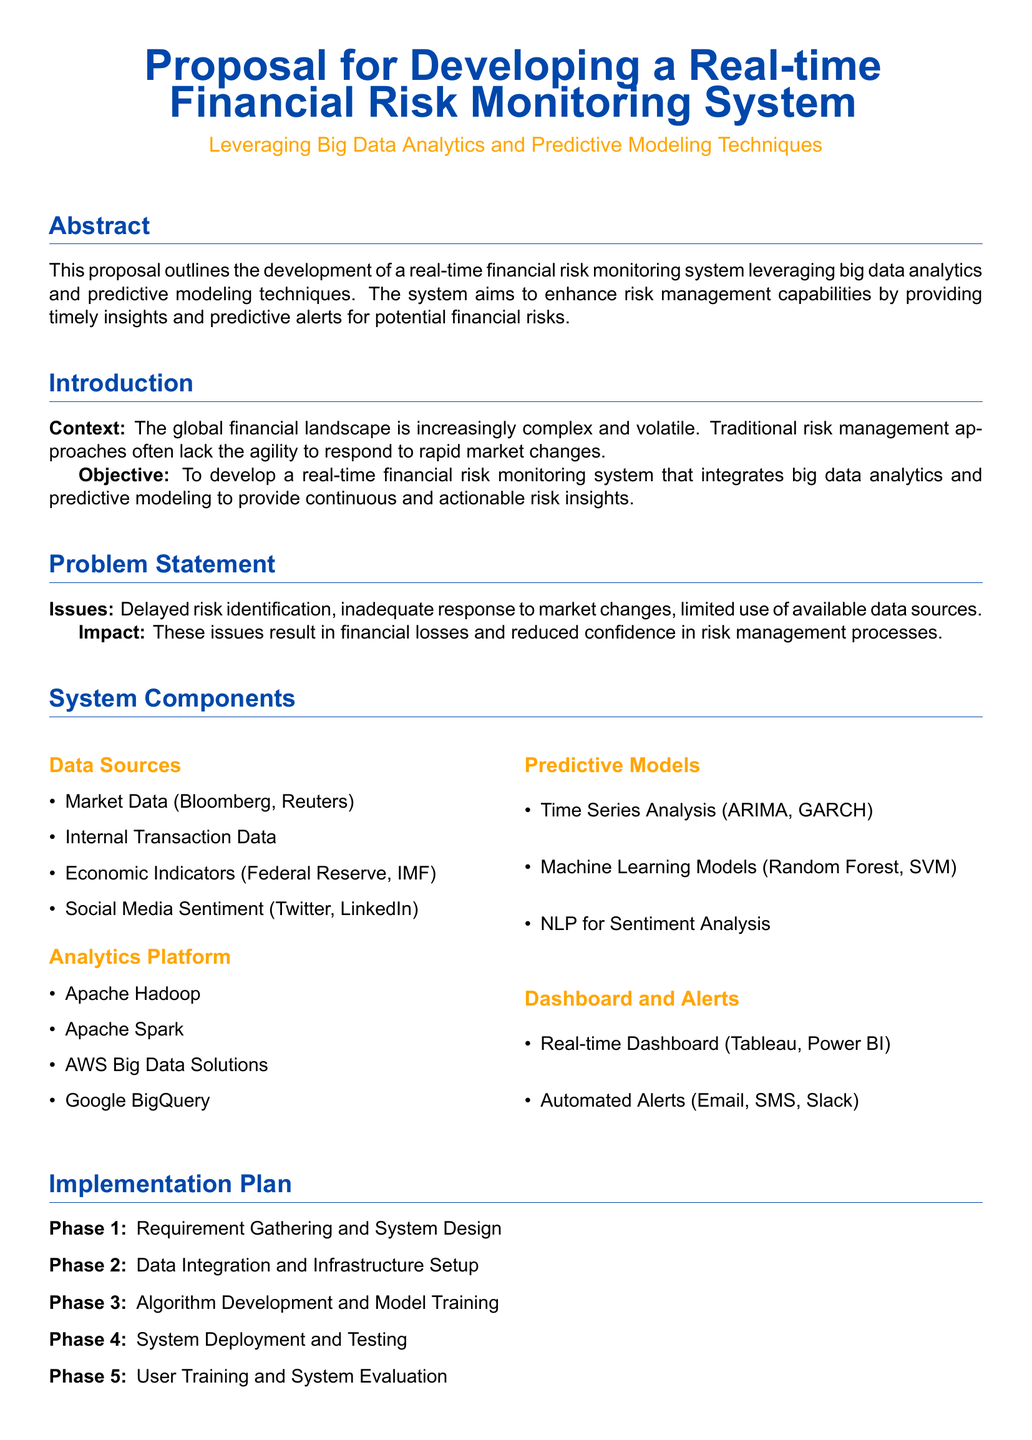What is the main aim of the proposal? The main aim of the proposal is to enhance risk management capabilities by providing timely insights and predictive alerts for potential financial risks.
Answer: Enhance risk management capabilities Which data sources are mentioned in the proposal? The proposal lists several data sources under System Components, specifically in the Data Sources section.
Answer: Market Data, Internal Transaction Data, Economic Indicators, Social Media Sentiment Which predictive modeling techniques are utilized? The types of predictive models are outlined in the Predictive Models subsection, indicating what models will be employed.
Answer: Time Series Analysis, Machine Learning Models, NLP for Sentiment Analysis How many phases are there in the Implementation Plan? The Implementation Plan outlines a series of phases for the project's rollout and specifies the number of phases involved.
Answer: Five What is one expected benefit of the proposed system? The Expected Benefits section highlights various advantages; choosing any of these will provide insight into the proposal's value proposition.
Answer: Enhanced Risk Visibility What platforms are suggested for the analytics platform? The analytics platform outlines specific technologies to be utilized for big data analytics in the proposal.
Answer: Apache Hadoop, Apache Spark, AWS Big Data Solutions, Google BigQuery What types of alerts are mentioned in the document? The Dashboard and Alerts section identifies how alerts will be communicated to users, providing insight into the notification system.
Answer: Email, SMS, Slack What is the context for developing this system? The introduction provides the backdrop for why the system is necessary, explaining the current challenges in risk management.
Answer: Increasing complexity and volatility of the financial landscape 